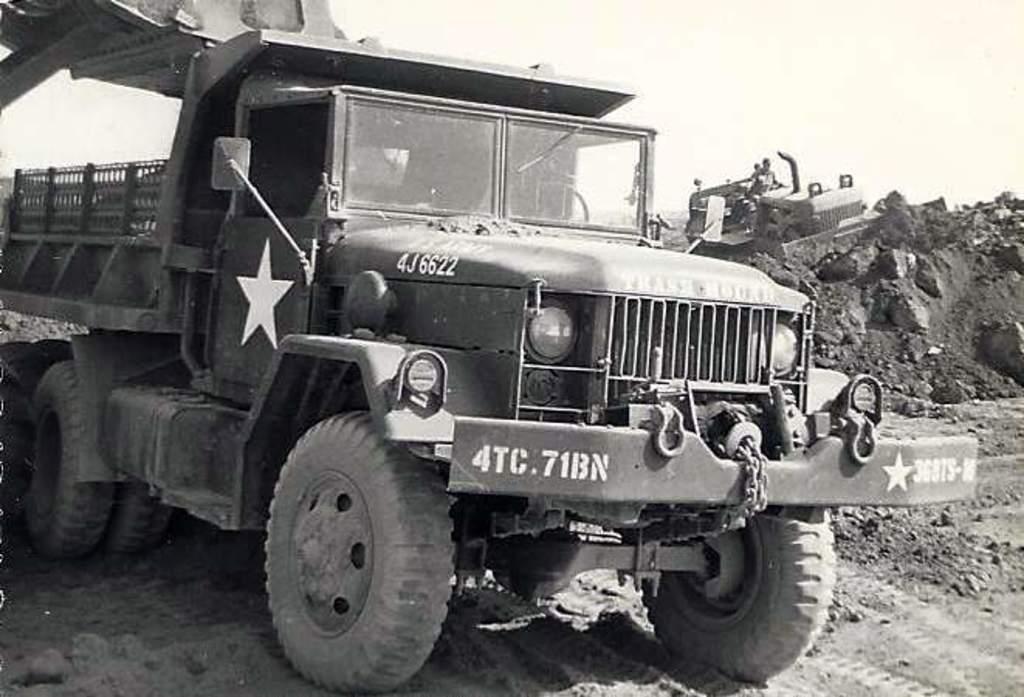Describe this image in one or two sentences. This is a black and white picture. I can see vehicles, there are rocks, and in the background there is the sky. 